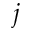<formula> <loc_0><loc_0><loc_500><loc_500>j</formula> 